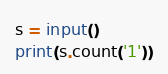Convert code to text. <code><loc_0><loc_0><loc_500><loc_500><_Python_>s = input()
print(s.count('1'))
</code> 